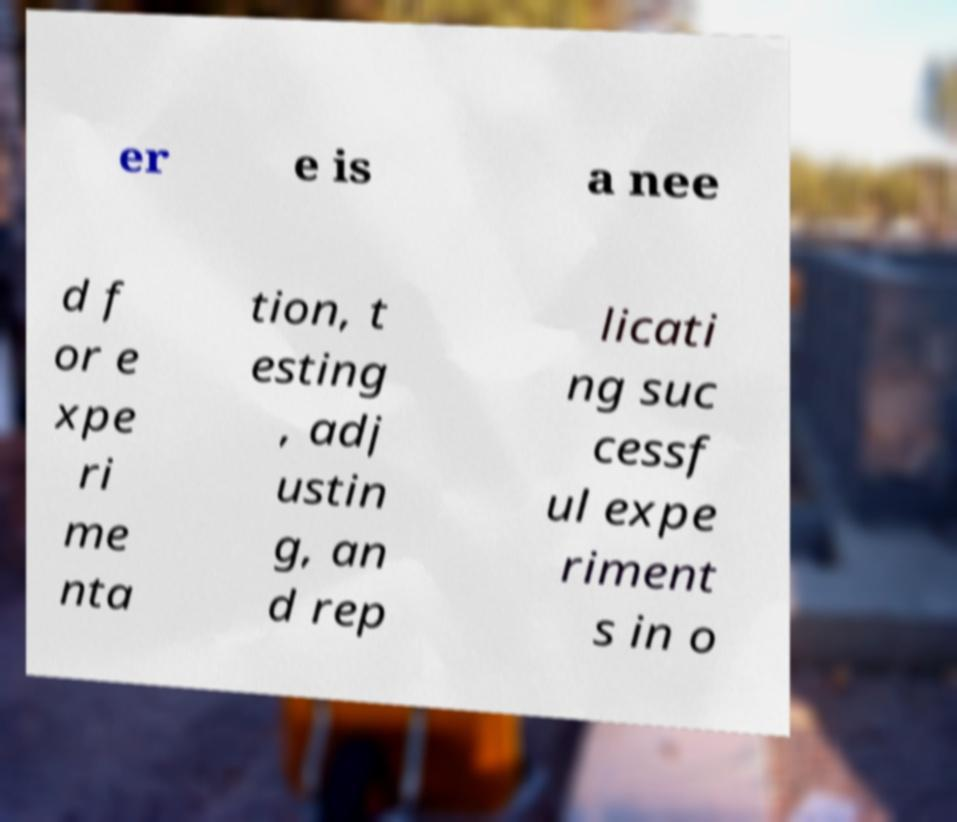For documentation purposes, I need the text within this image transcribed. Could you provide that? er e is a nee d f or e xpe ri me nta tion, t esting , adj ustin g, an d rep licati ng suc cessf ul expe riment s in o 